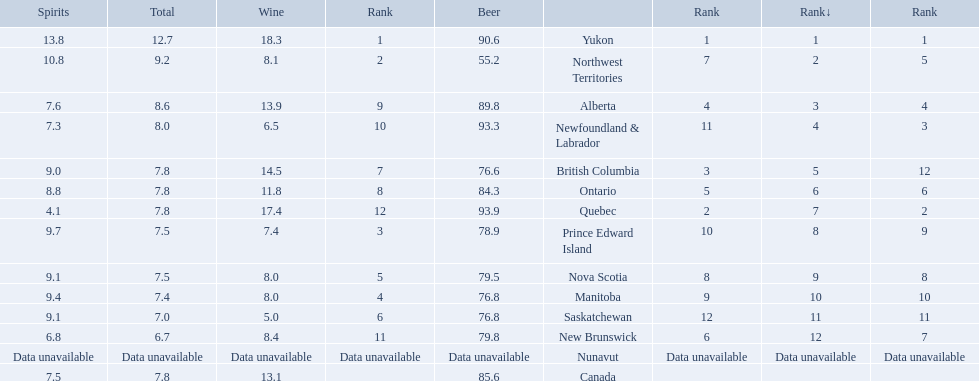Which locations consume the same total amount of alcoholic beverages as another location? British Columbia, Ontario, Quebec, Prince Edward Island, Nova Scotia. Which of these consumes more then 80 of beer? Ontario, Quebec. Of those what was the consumption of spirits of the one that consumed the most beer? 4.1. 